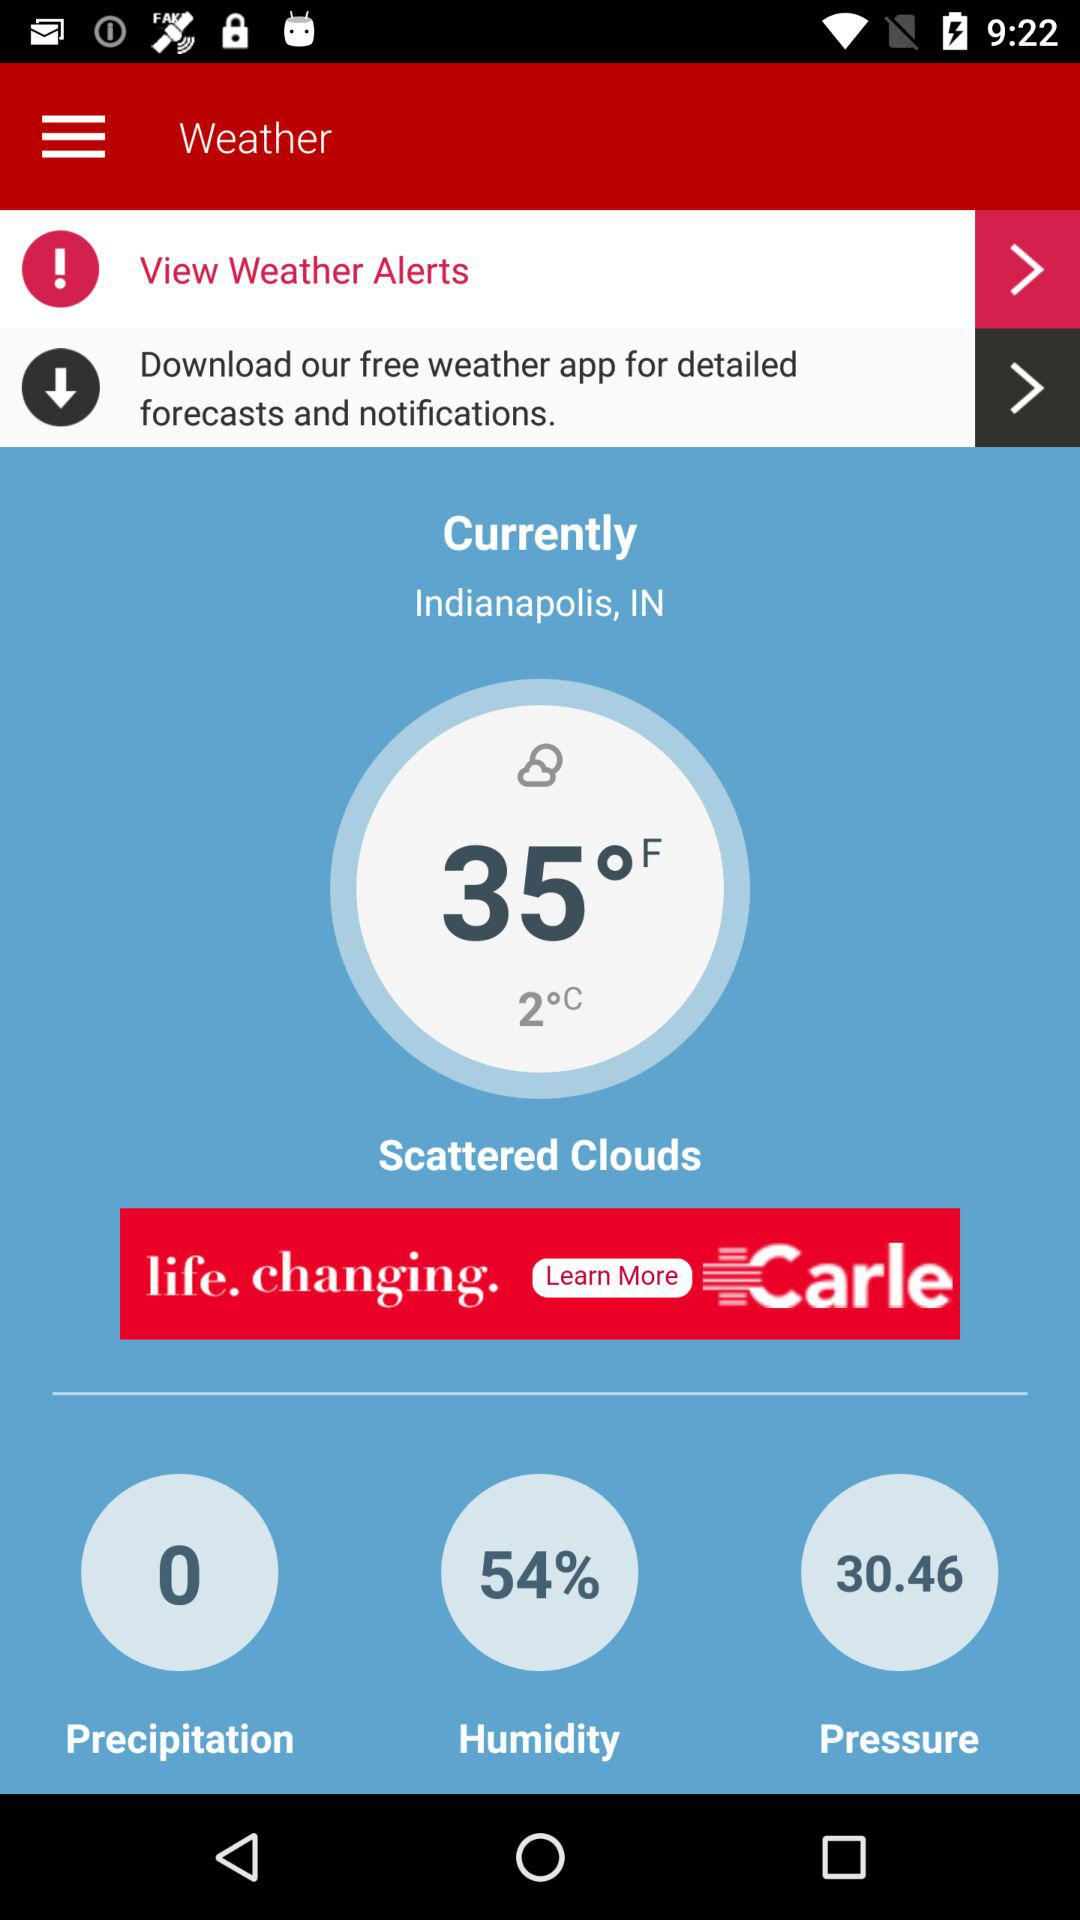How many degrees Fahrenheit is the temperature?
Answer the question using a single word or phrase. 35°F 